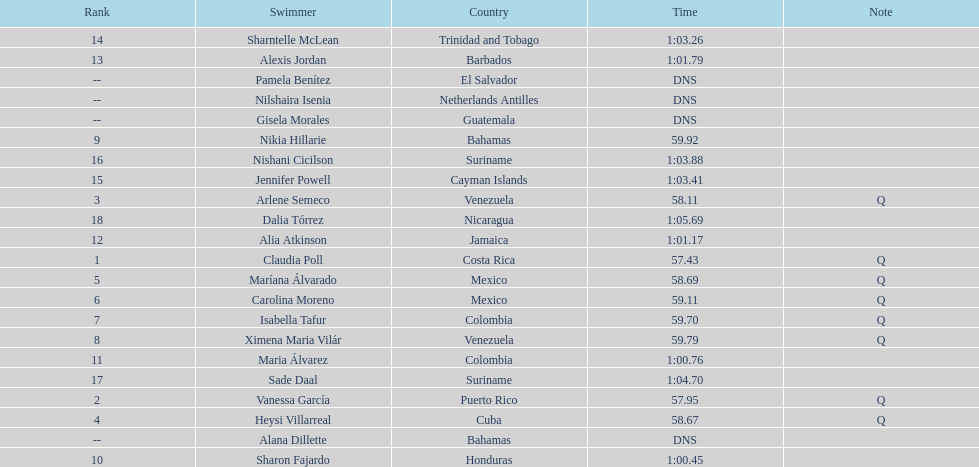How many swimmers are from mexico? 2. 